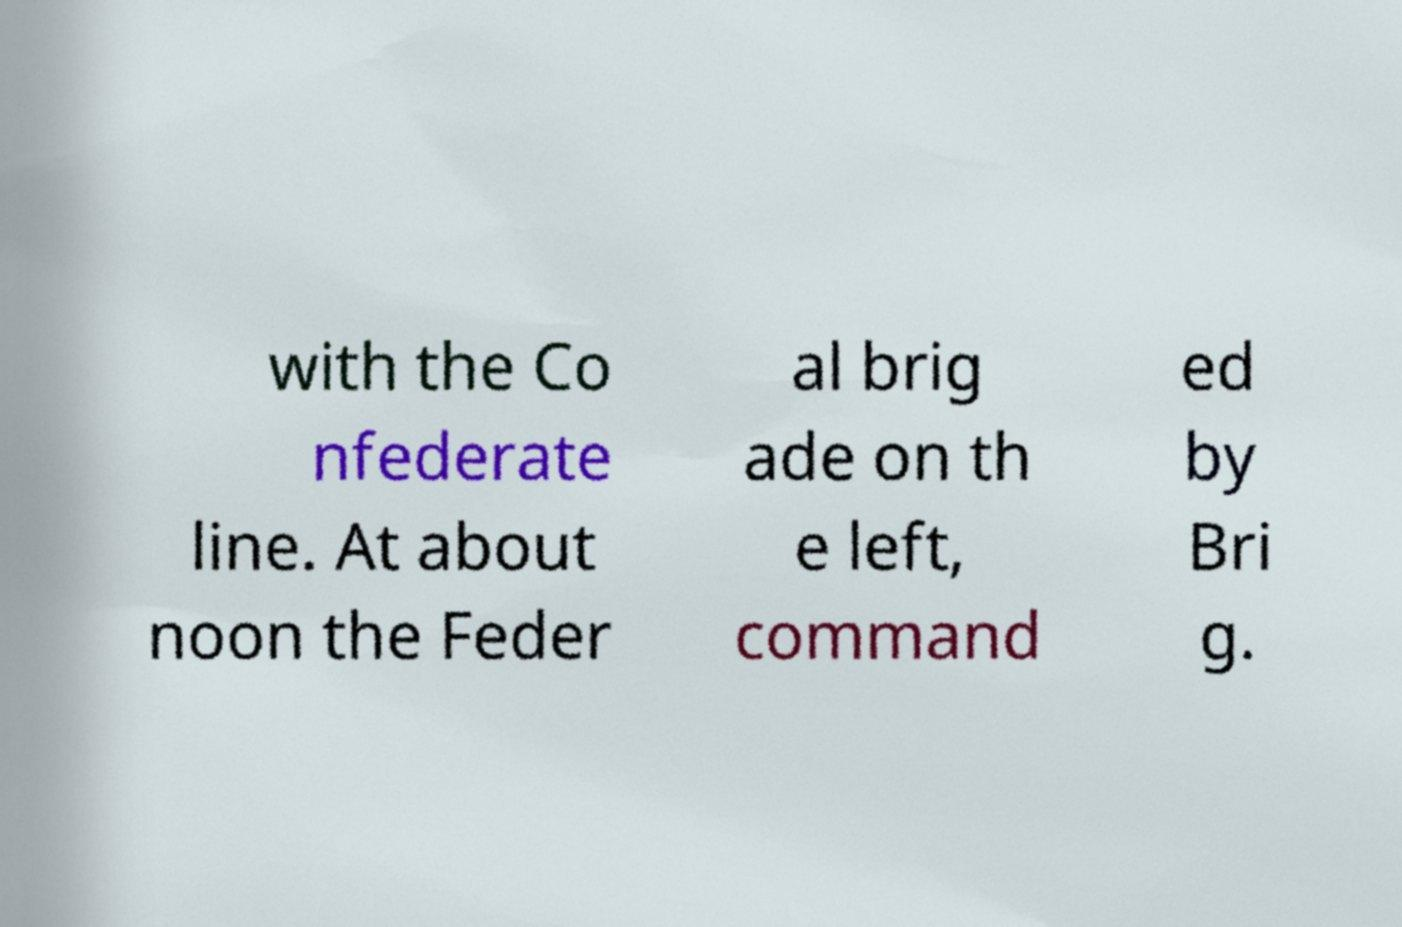Can you accurately transcribe the text from the provided image for me? with the Co nfederate line. At about noon the Feder al brig ade on th e left, command ed by Bri g. 